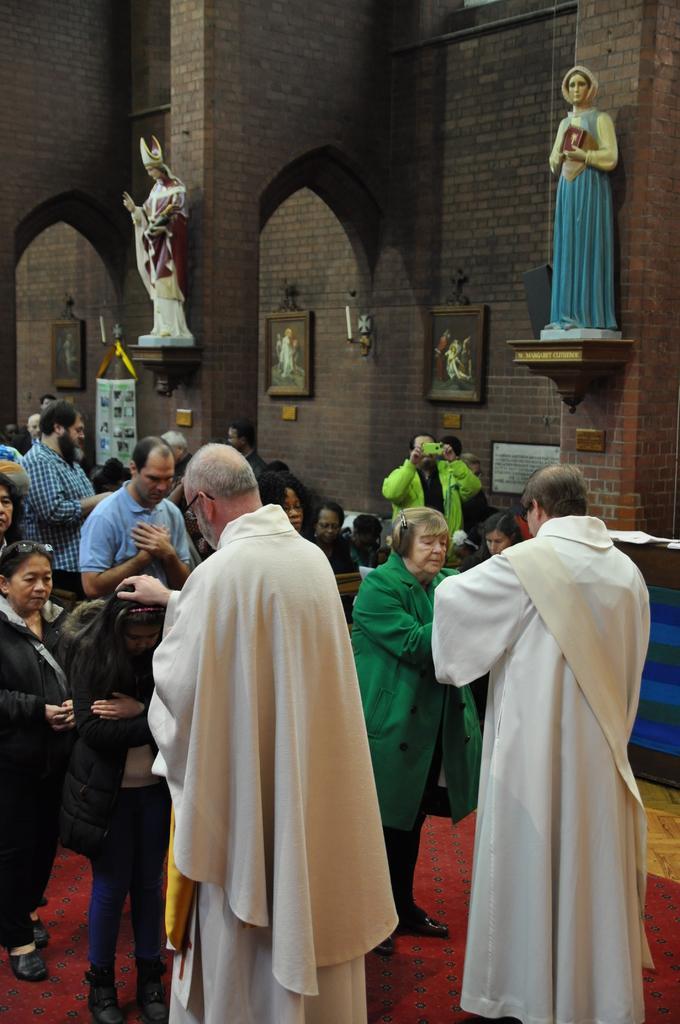How would you summarize this image in a sentence or two? This picture describes about group of people, in the background we can see few statues and frames on the wall, also we can see a person is holding a camera. 